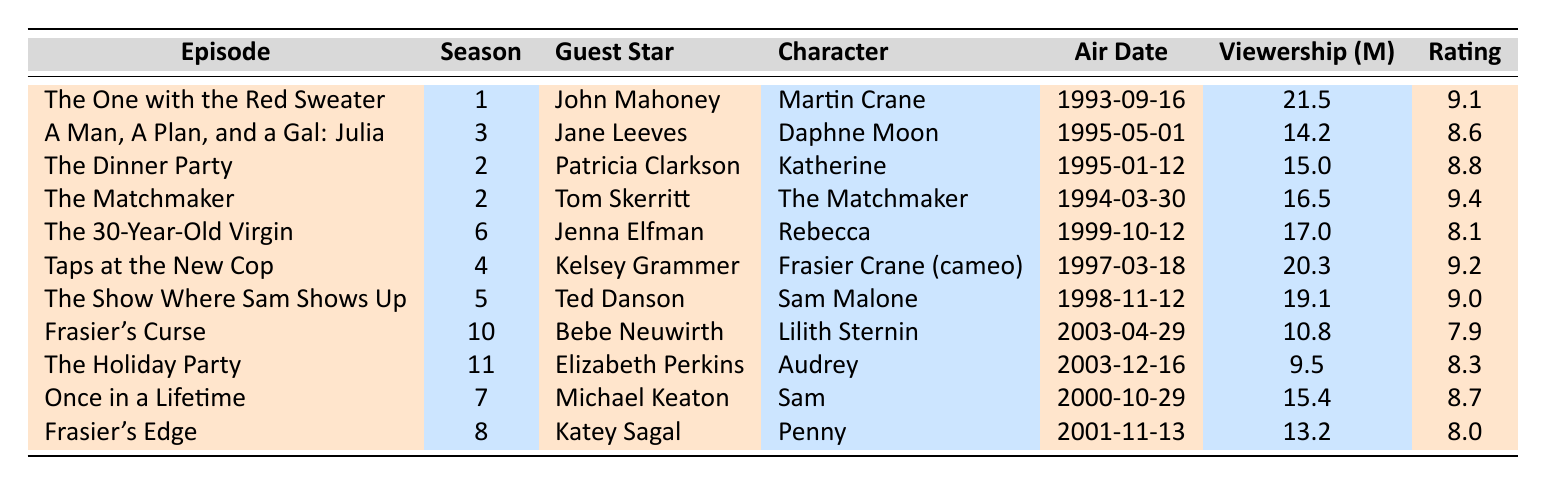What is the guest star in the episode "The Dinner Party"? The episode "The Dinner Party" features Patricia Clarkson as the guest star.
Answer: Patricia Clarkson Which episode has the highest viewership? The episode with the highest viewership is "The One with the Red Sweater," which has 21.5 million viewers.
Answer: 21.5 million What was the rating for "Frasier's Curse"? The rating for the episode "Frasier's Curse" is 7.9.
Answer: 7.9 What is the average rating for the episodes featuring Kelsey Grammer? Kelsey Grammer appears in "Taps at the New Cop," which has a rating of 9.2. This gives an average rating of 9.2 since there's only one episode.
Answer: 9.2 Which character did Jane Leeves portray? Jane Leeves portrayed the character Daphne Moon in "A Man, A Plan, and a Gal: Julia."
Answer: Daphne Moon How many guest stars have a ratings score over 9? The guest stars with ratings over 9 are John Mahoney (9.1), Tom Skerritt (9.4), Kelsey Grammer (9.2), Ted Danson (9.0). That totals four guest stars.
Answer: Four Which episode featuring a guest star had the lowest viewership? The episode "The Holiday Party," featuring Elizabeth Perkins, had the lowest viewership at 9.5 million.
Answer: 9.5 million What is the total viewership of all episodes featuring Bebe Neuwirth? Bebe Neuwirth appears in "Frasier's Curse," which has a viewership of 10.8 million. So, the total is 10.8 million.
Answer: 10.8 million Is it true that all episodes in season 2 have ratings above 8? In season 2, "The Dinner Party" has a rating of 8.8 and "The Matchmaker" has a rating of 9.4, so both episodes have ratings above 8, making the statement true.
Answer: Yes What is the difference in viewership between the highest and lowest viewed episode? The highest viewed episode is "The One with the Red Sweater" (21.5 million) and the lowest viewed episode is "The Holiday Party" (9.5 million). Their difference is 21.5 - 9.5 = 12 million.
Answer: 12 million What percentage of episodes had viewership below 15 million? There are 11 episodes total, and 5 of them have viewership below 15 million. To find the percentage: (5/11)*100 ≈ 45.45%.
Answer: 45.45% 